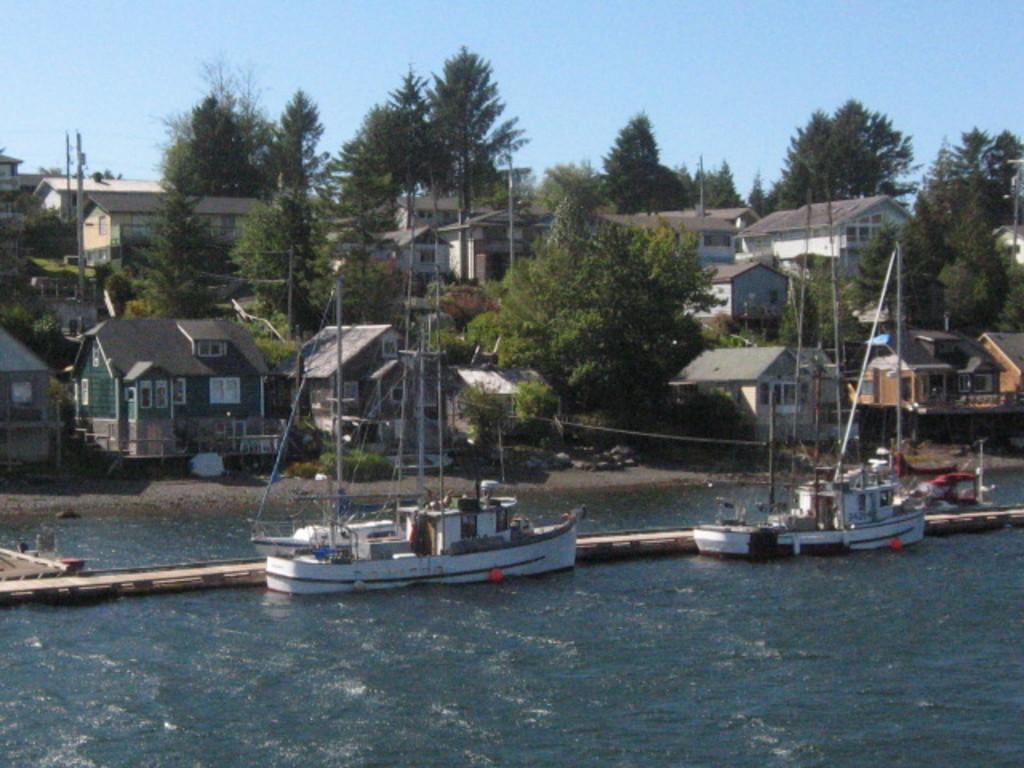What is happening in the water in the image? There are ships sailing on the water in the image. What is located near the ships? There is a small bridge beside the ships. What structures can be seen in the background of the image? There are buildings visible in the image. What type of vegetation is present at the bank of the river? Trees are present at the bank of the river in the image. How many clocks are hanging on the trees in the image? There are no clocks hanging on the trees in the image. What type of yard is visible in the image? There is no yard present in the image; it features ships sailing on the water, a small bridge, buildings, and trees at the bank of the river. 